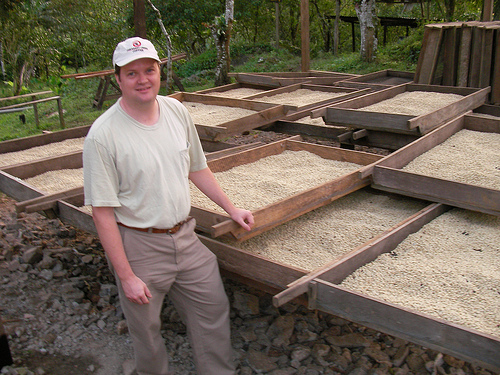<image>
Is there a hat on the man? Yes. Looking at the image, I can see the hat is positioned on top of the man, with the man providing support. 